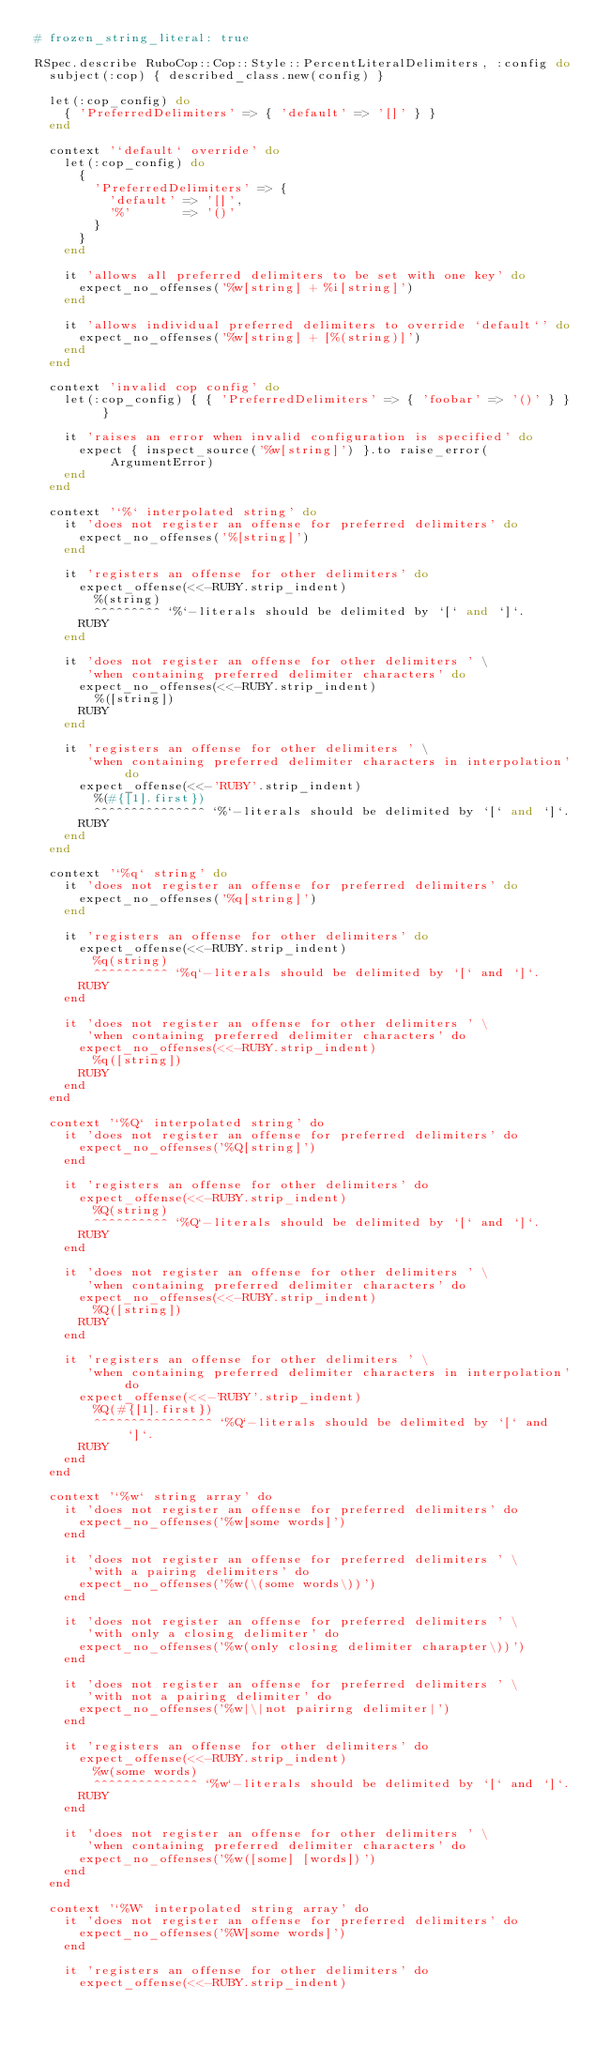<code> <loc_0><loc_0><loc_500><loc_500><_Ruby_># frozen_string_literal: true

RSpec.describe RuboCop::Cop::Style::PercentLiteralDelimiters, :config do
  subject(:cop) { described_class.new(config) }

  let(:cop_config) do
    { 'PreferredDelimiters' => { 'default' => '[]' } }
  end

  context '`default` override' do
    let(:cop_config) do
      {
        'PreferredDelimiters' => {
          'default' => '[]',
          '%'       => '()'
        }
      }
    end

    it 'allows all preferred delimiters to be set with one key' do
      expect_no_offenses('%w[string] + %i[string]')
    end

    it 'allows individual preferred delimiters to override `default`' do
      expect_no_offenses('%w[string] + [%(string)]')
    end
  end

  context 'invalid cop config' do
    let(:cop_config) { { 'PreferredDelimiters' => { 'foobar' => '()' } } }

    it 'raises an error when invalid configuration is specified' do
      expect { inspect_source('%w[string]') }.to raise_error(ArgumentError)
    end
  end

  context '`%` interpolated string' do
    it 'does not register an offense for preferred delimiters' do
      expect_no_offenses('%[string]')
    end

    it 'registers an offense for other delimiters' do
      expect_offense(<<-RUBY.strip_indent)
        %(string)
        ^^^^^^^^^ `%`-literals should be delimited by `[` and `]`.
      RUBY
    end

    it 'does not register an offense for other delimiters ' \
       'when containing preferred delimiter characters' do
      expect_no_offenses(<<-RUBY.strip_indent)
        %([string])
      RUBY
    end

    it 'registers an offense for other delimiters ' \
       'when containing preferred delimiter characters in interpolation' do
      expect_offense(<<-'RUBY'.strip_indent)
        %(#{[1].first})
        ^^^^^^^^^^^^^^^ `%`-literals should be delimited by `[` and `]`.
      RUBY
    end
  end

  context '`%q` string' do
    it 'does not register an offense for preferred delimiters' do
      expect_no_offenses('%q[string]')
    end

    it 'registers an offense for other delimiters' do
      expect_offense(<<-RUBY.strip_indent)
        %q(string)
        ^^^^^^^^^^ `%q`-literals should be delimited by `[` and `]`.
      RUBY
    end

    it 'does not register an offense for other delimiters ' \
       'when containing preferred delimiter characters' do
      expect_no_offenses(<<-RUBY.strip_indent)
        %q([string])
      RUBY
    end
  end

  context '`%Q` interpolated string' do
    it 'does not register an offense for preferred delimiters' do
      expect_no_offenses('%Q[string]')
    end

    it 'registers an offense for other delimiters' do
      expect_offense(<<-RUBY.strip_indent)
        %Q(string)
        ^^^^^^^^^^ `%Q`-literals should be delimited by `[` and `]`.
      RUBY
    end

    it 'does not register an offense for other delimiters ' \
       'when containing preferred delimiter characters' do
      expect_no_offenses(<<-RUBY.strip_indent)
        %Q([string])
      RUBY
    end

    it 'registers an offense for other delimiters ' \
       'when containing preferred delimiter characters in interpolation' do
      expect_offense(<<-'RUBY'.strip_indent)
        %Q(#{[1].first})
        ^^^^^^^^^^^^^^^^ `%Q`-literals should be delimited by `[` and `]`.
      RUBY
    end
  end

  context '`%w` string array' do
    it 'does not register an offense for preferred delimiters' do
      expect_no_offenses('%w[some words]')
    end

    it 'does not register an offense for preferred delimiters ' \
       'with a pairing delimiters' do
      expect_no_offenses('%w(\(some words\))')
    end

    it 'does not register an offense for preferred delimiters ' \
       'with only a closing delimiter' do
      expect_no_offenses('%w(only closing delimiter charapter\))')
    end

    it 'does not register an offense for preferred delimiters ' \
       'with not a pairing delimiter' do
      expect_no_offenses('%w|\|not pairirng delimiter|')
    end

    it 'registers an offense for other delimiters' do
      expect_offense(<<-RUBY.strip_indent)
        %w(some words)
        ^^^^^^^^^^^^^^ `%w`-literals should be delimited by `[` and `]`.
      RUBY
    end

    it 'does not register an offense for other delimiters ' \
       'when containing preferred delimiter characters' do
      expect_no_offenses('%w([some] [words])')
    end
  end

  context '`%W` interpolated string array' do
    it 'does not register an offense for preferred delimiters' do
      expect_no_offenses('%W[some words]')
    end

    it 'registers an offense for other delimiters' do
      expect_offense(<<-RUBY.strip_indent)</code> 